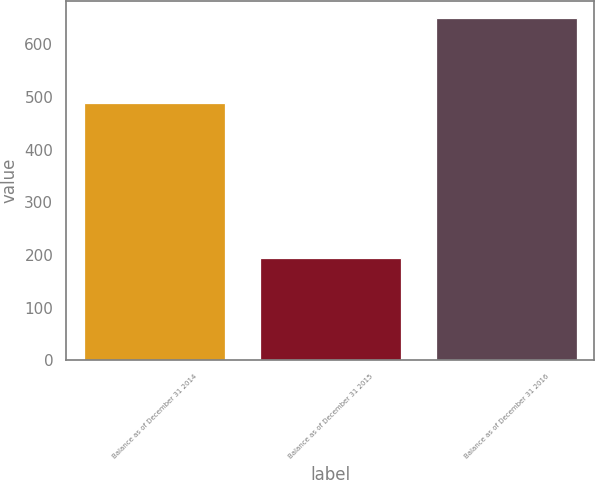Convert chart. <chart><loc_0><loc_0><loc_500><loc_500><bar_chart><fcel>Balance as of December 31 2014<fcel>Balance as of December 31 2015<fcel>Balance as of December 31 2016<nl><fcel>488<fcel>194<fcel>650<nl></chart> 